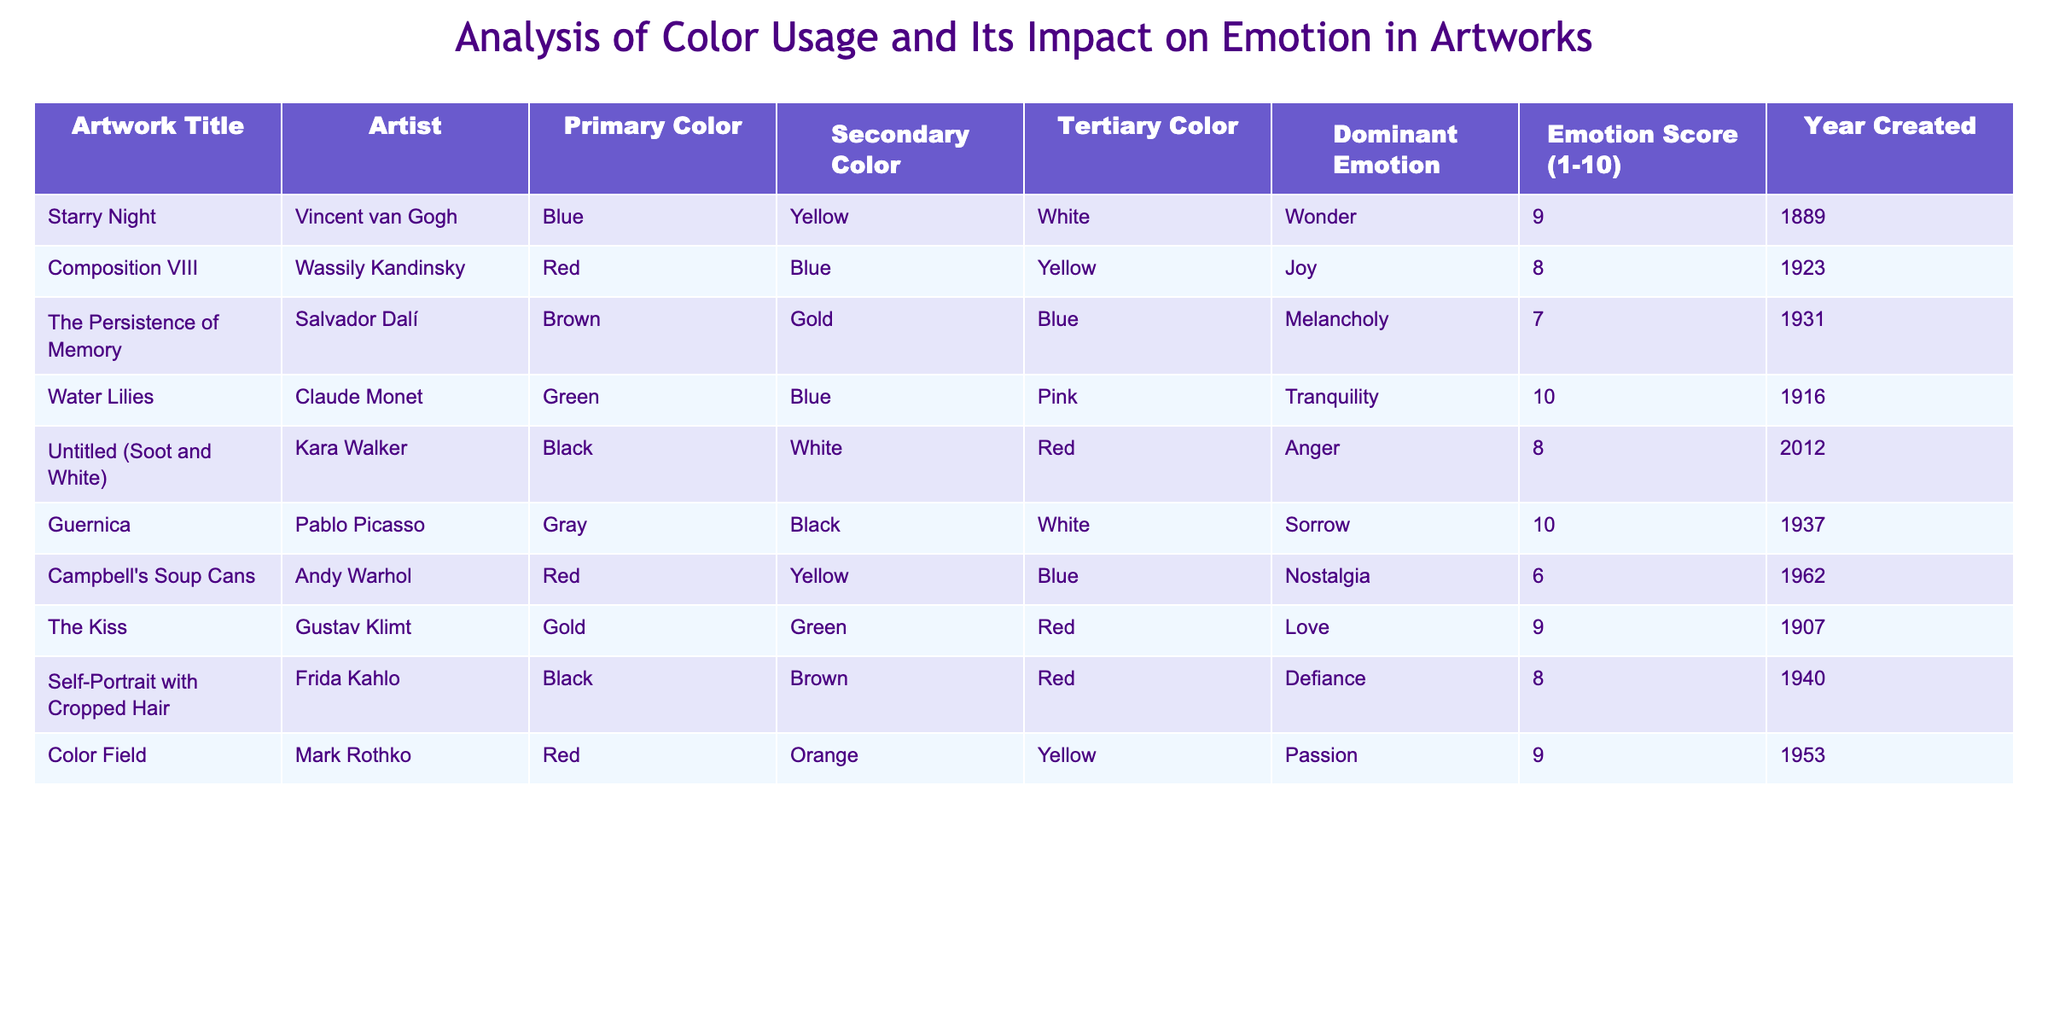What is the dominant emotion for "The Persistence of Memory"? The table shows that the dominant emotion for "The Persistence of Memory", created by Salvador Dalí, is listed as "Melancholy".
Answer: Melancholy Which artwork has the highest emotion score? By reviewing the emotion scores in the table, "Water Lilies" by Claude Monet has the highest score of 10, indicating it evokes a strong feeling.
Answer: Water Lilies How many artworks are associated with the color red? The table lists three artworks that have red as their primary color: "Composition VIII", "Campbell's Soup Cans", and "Color Field".
Answer: Three What is the average emotion score for artworks created after 2000? Artworks created after 2000 are "Untitled (Soot and White)" and its score is 8. Since there are only two artworks after 2000, the average is 8 / 1 = 8.
Answer: 8 Is there a connection between color usage and dominant emotion? Analyzing the table suggests there is a connection, as multiple artworks demonstrate that specific colors correspond with certain emotions, like blue with wonder and green with tranquility. However, this requires further study to be conclusive.
Answer: Yes Which artist has created the artwork with the lowest emotion score, and what is that score? The artwork with the lowest emotion score is "Campbell's Soup Cans" by Andy Warhol, with a score of 6. This can be seen clearly in the emotion score column.
Answer: Andy Warhol, 6 If you arrange the artworks by emotion score from highest to lowest, what are the top three artworks? The top three artworks by emotion score are: "Water Lilies" (10), "Guernica" (10), and "Starry Night" (9). This is determined by sorting the emotion scores in descending order.
Answer: Water Lilies, Guernica, Starry Night What is the difference between the highest and lowest emotion scores in the table? The highest emotion score is 10 (from "Water Lilies" and "Guernica"), and the lowest is 6 (from "Campbell's Soup Cans"). Thus, the difference is 10 - 6 = 4.
Answer: 4 